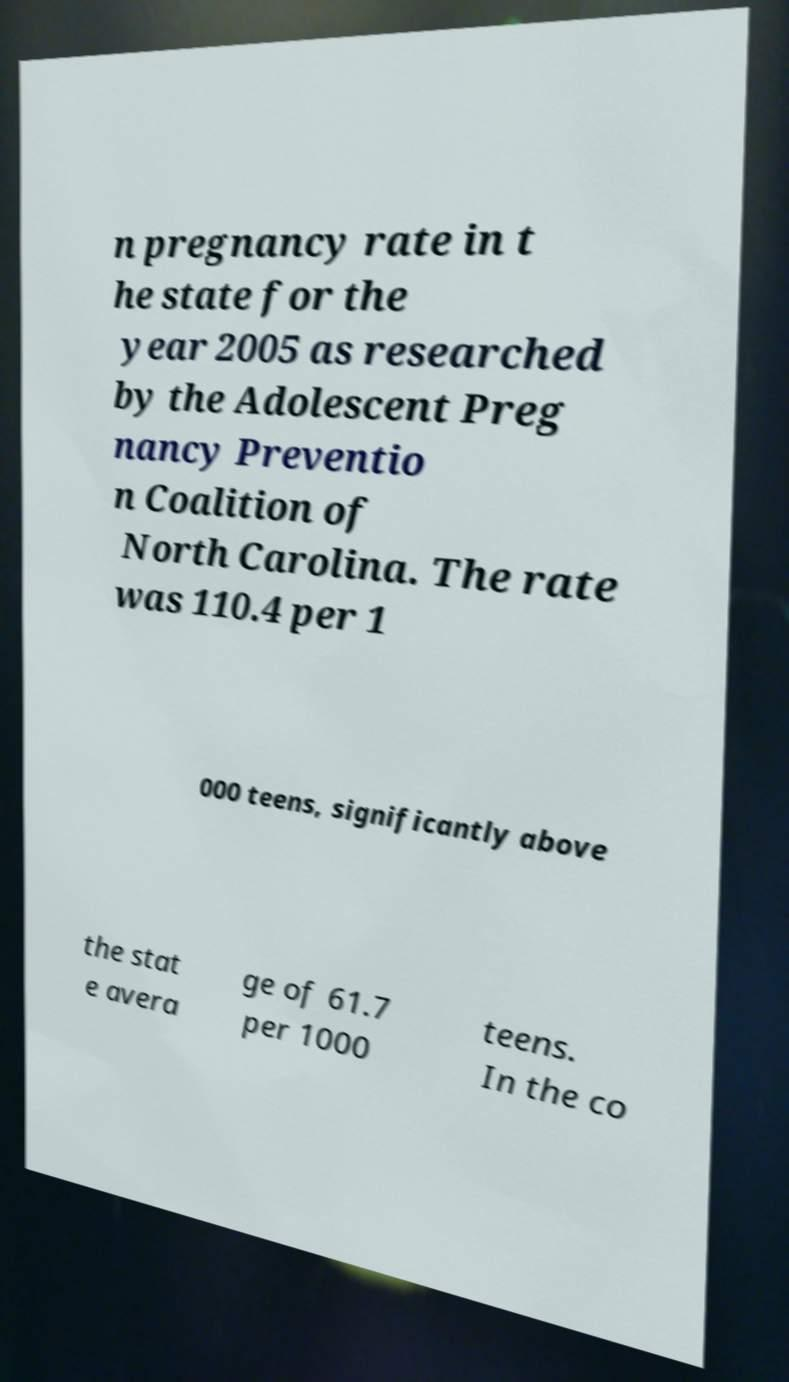Can you read and provide the text displayed in the image?This photo seems to have some interesting text. Can you extract and type it out for me? n pregnancy rate in t he state for the year 2005 as researched by the Adolescent Preg nancy Preventio n Coalition of North Carolina. The rate was 110.4 per 1 000 teens, significantly above the stat e avera ge of 61.7 per 1000 teens. In the co 